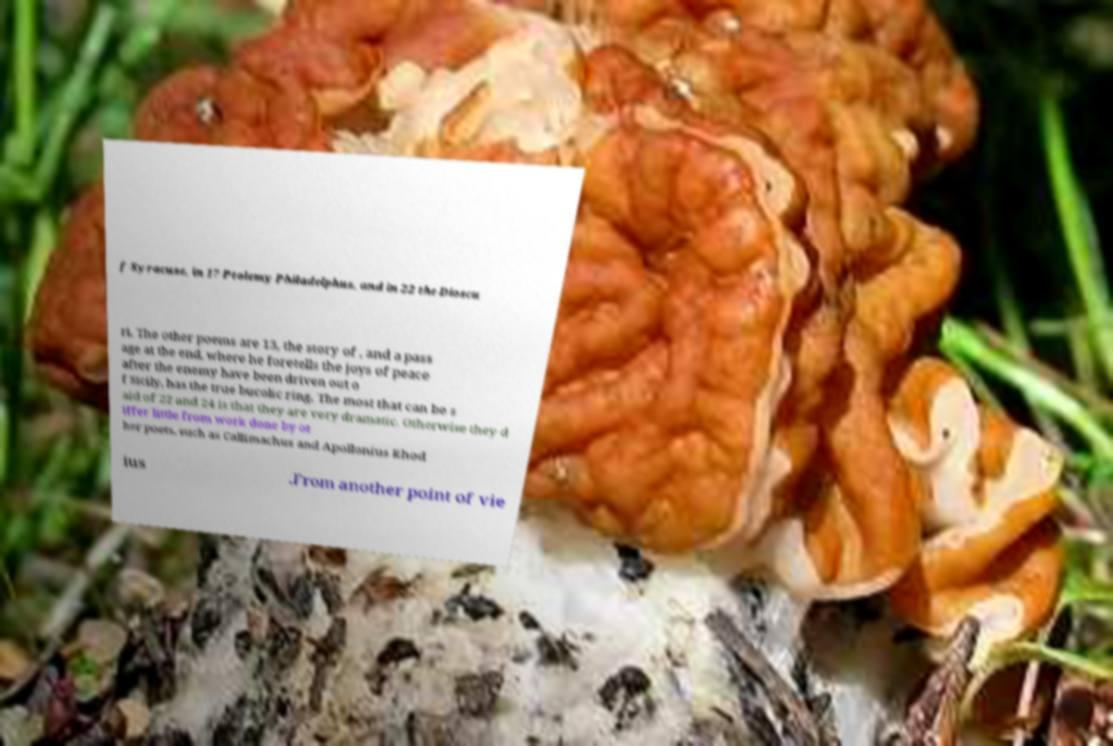Could you assist in decoding the text presented in this image and type it out clearly? f Syracuse, in 17 Ptolemy Philadelphus, and in 22 the Dioscu ri. The other poems are 13, the story of , and a pass age at the end, where he foretells the joys of peace after the enemy have been driven out o f Sicily, has the true bucolic ring. The most that can be s aid of 22 and 24 is that they are very dramatic. Otherwise they d iffer little from work done by ot her poets, such as Callimachus and Apollonius Rhod ius .From another point of vie 